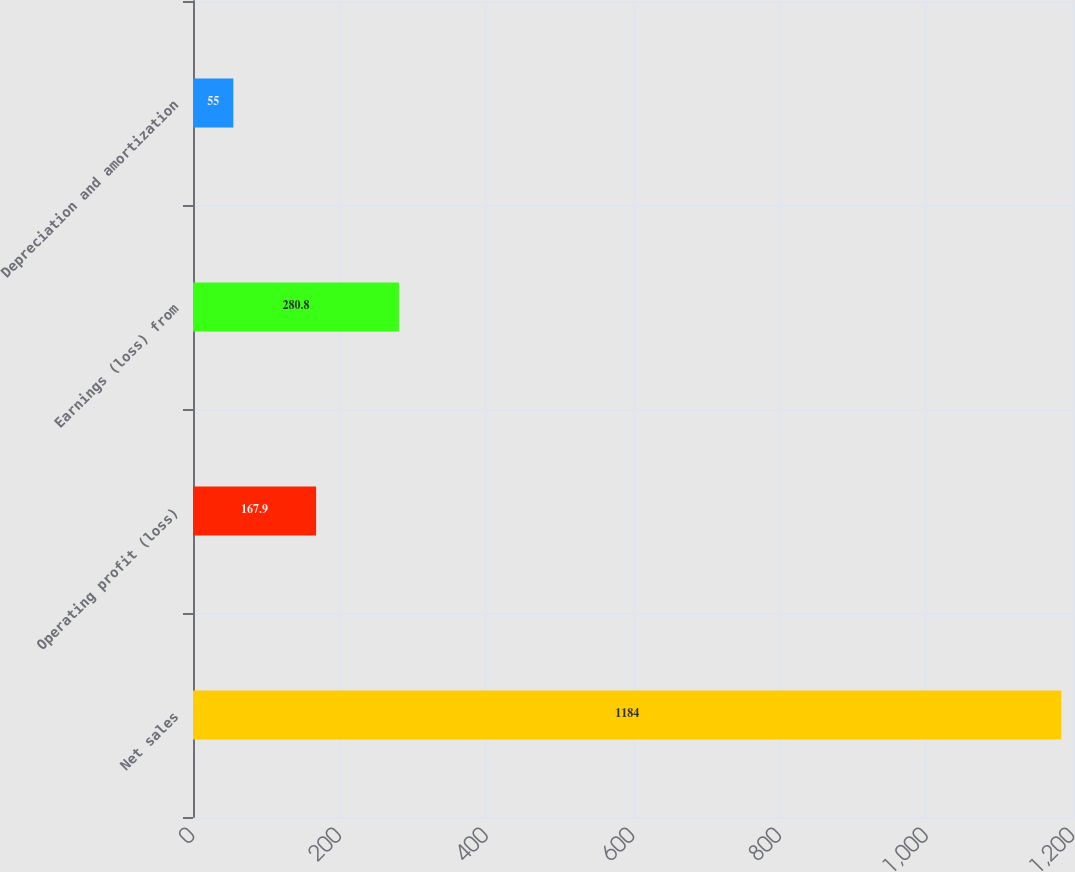<chart> <loc_0><loc_0><loc_500><loc_500><bar_chart><fcel>Net sales<fcel>Operating profit (loss)<fcel>Earnings (loss) from<fcel>Depreciation and amortization<nl><fcel>1184<fcel>167.9<fcel>280.8<fcel>55<nl></chart> 